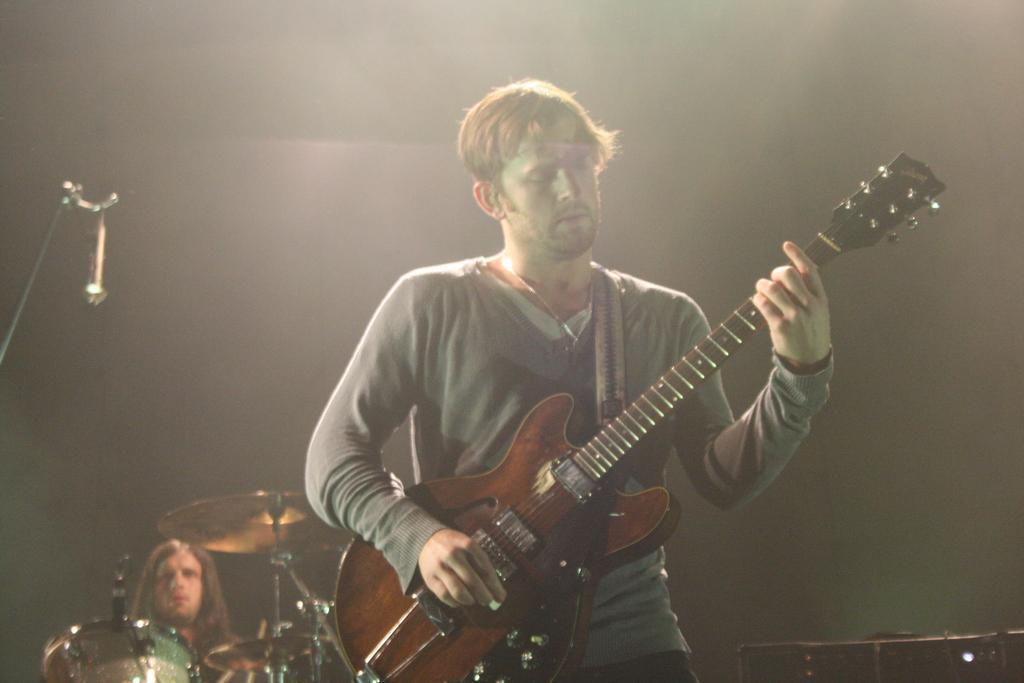In one or two sentences, can you explain what this image depicts? This picture shows a man standing and playing guitar and we see a man seated and playing drums on the back 